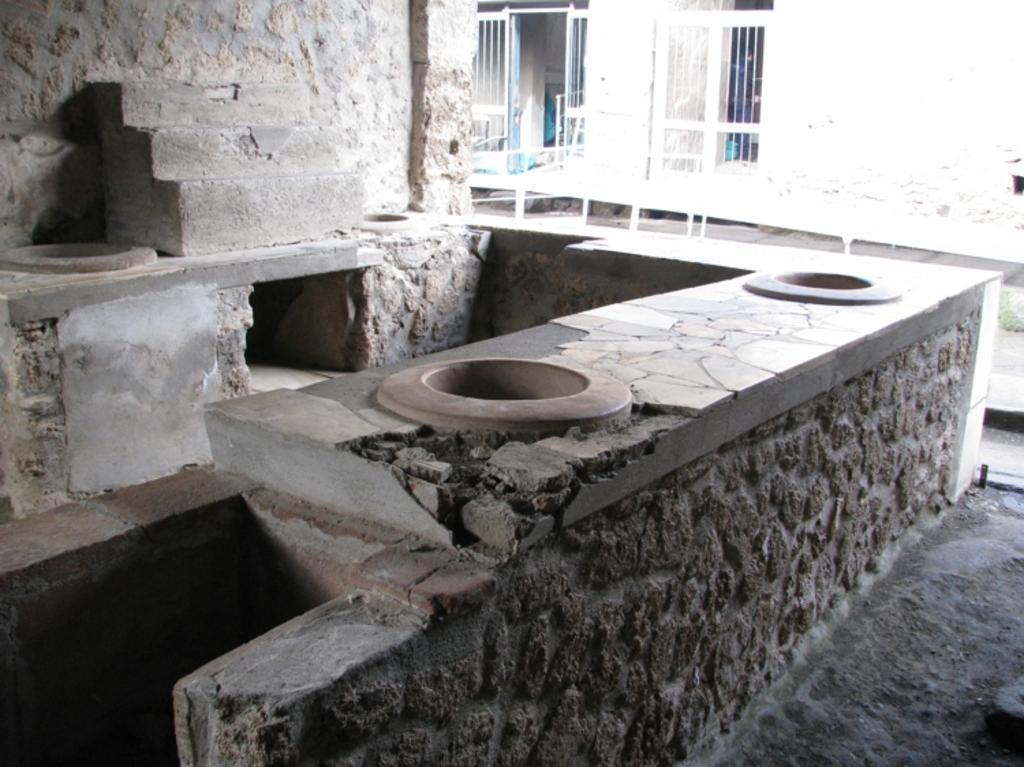Can you describe this image briefly? In this picture we can see steps, wall, floor and in the background we can see windows. 